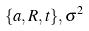Convert formula to latex. <formula><loc_0><loc_0><loc_500><loc_500>\{ a , R , t \} , \sigma ^ { 2 }</formula> 